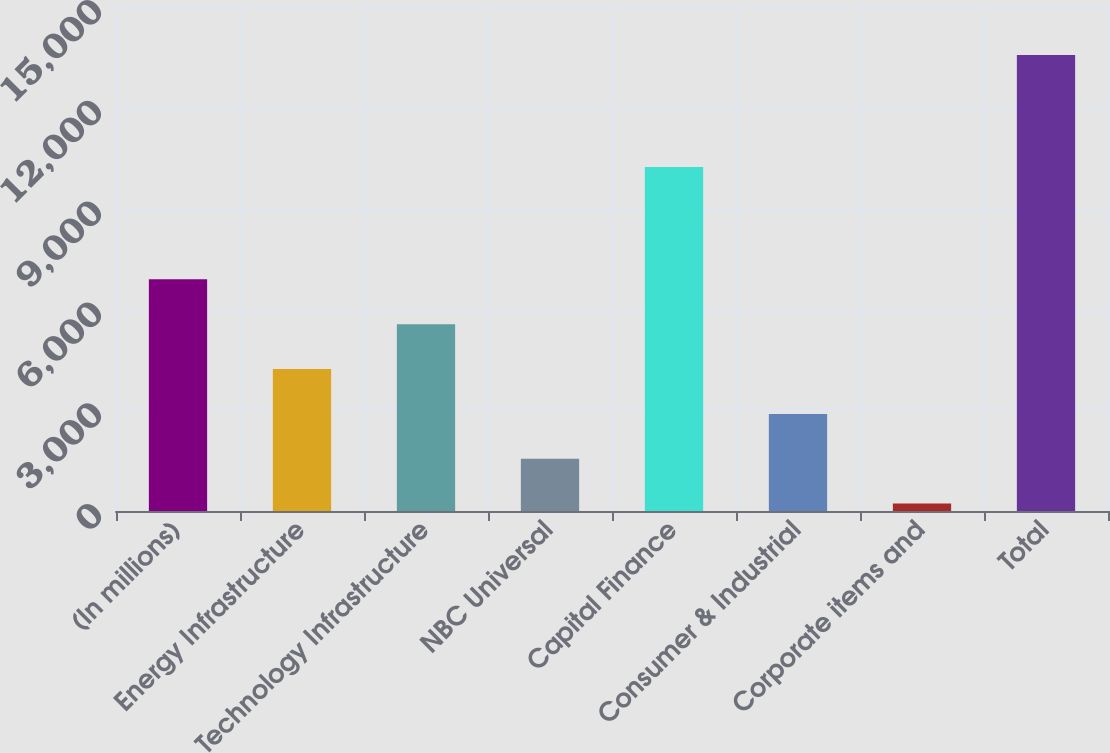Convert chart. <chart><loc_0><loc_0><loc_500><loc_500><bar_chart><fcel>(In millions)<fcel>Energy Infrastructure<fcel>Technology Infrastructure<fcel>NBC Universal<fcel>Capital Finance<fcel>Consumer & Industrial<fcel>Corporate items and<fcel>Total<nl><fcel>6894.5<fcel>4225.1<fcel>5559.8<fcel>1555.7<fcel>10238<fcel>2890.4<fcel>221<fcel>13568<nl></chart> 